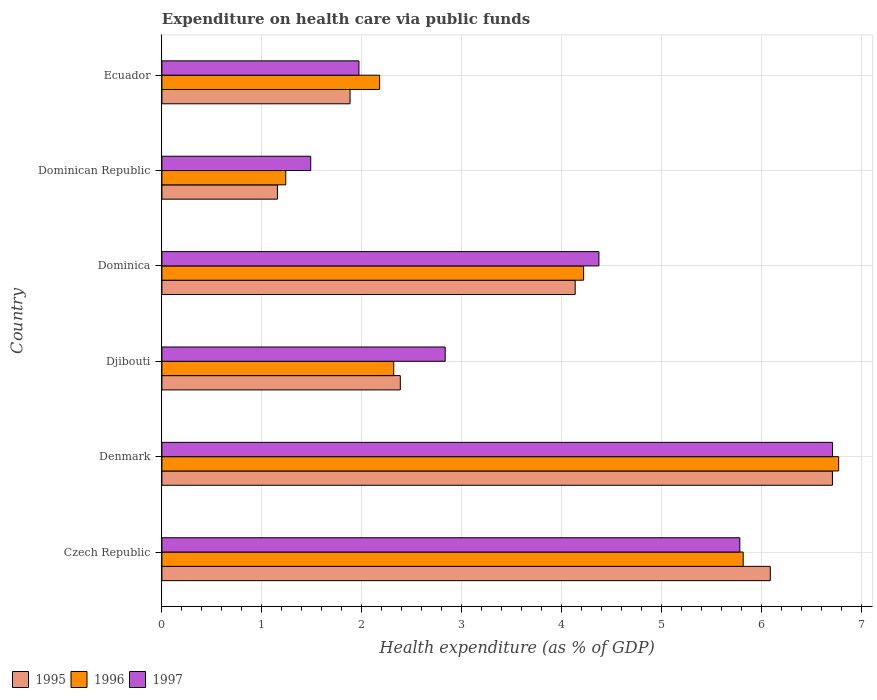How many different coloured bars are there?
Give a very brief answer. 3. Are the number of bars on each tick of the Y-axis equal?
Your answer should be very brief. Yes. What is the label of the 6th group of bars from the top?
Your response must be concise. Czech Republic. What is the expenditure made on health care in 1997 in Djibouti?
Give a very brief answer. 2.83. Across all countries, what is the maximum expenditure made on health care in 1995?
Give a very brief answer. 6.71. Across all countries, what is the minimum expenditure made on health care in 1996?
Give a very brief answer. 1.24. In which country was the expenditure made on health care in 1996 minimum?
Provide a short and direct response. Dominican Republic. What is the total expenditure made on health care in 1995 in the graph?
Keep it short and to the point. 22.34. What is the difference between the expenditure made on health care in 1997 in Czech Republic and that in Dominican Republic?
Provide a succinct answer. 4.29. What is the difference between the expenditure made on health care in 1995 in Denmark and the expenditure made on health care in 1997 in Dominica?
Offer a terse response. 2.34. What is the average expenditure made on health care in 1996 per country?
Make the answer very short. 3.76. What is the difference between the expenditure made on health care in 1996 and expenditure made on health care in 1995 in Dominica?
Give a very brief answer. 0.08. What is the ratio of the expenditure made on health care in 1996 in Denmark to that in Dominican Republic?
Provide a succinct answer. 5.46. Is the difference between the expenditure made on health care in 1996 in Dominica and Dominican Republic greater than the difference between the expenditure made on health care in 1995 in Dominica and Dominican Republic?
Your answer should be compact. Yes. What is the difference between the highest and the second highest expenditure made on health care in 1996?
Offer a terse response. 0.95. What is the difference between the highest and the lowest expenditure made on health care in 1997?
Give a very brief answer. 5.22. Is the sum of the expenditure made on health care in 1997 in Denmark and Dominica greater than the maximum expenditure made on health care in 1996 across all countries?
Provide a short and direct response. Yes. What does the 3rd bar from the bottom in Ecuador represents?
Provide a short and direct response. 1997. Are all the bars in the graph horizontal?
Your response must be concise. Yes. Does the graph contain any zero values?
Ensure brevity in your answer.  No. Does the graph contain grids?
Make the answer very short. Yes. Where does the legend appear in the graph?
Offer a terse response. Bottom left. How many legend labels are there?
Provide a succinct answer. 3. What is the title of the graph?
Ensure brevity in your answer.  Expenditure on health care via public funds. What is the label or title of the X-axis?
Your response must be concise. Health expenditure (as % of GDP). What is the label or title of the Y-axis?
Ensure brevity in your answer.  Country. What is the Health expenditure (as % of GDP) of 1995 in Czech Republic?
Keep it short and to the point. 6.08. What is the Health expenditure (as % of GDP) of 1996 in Czech Republic?
Provide a short and direct response. 5.81. What is the Health expenditure (as % of GDP) of 1997 in Czech Republic?
Provide a succinct answer. 5.78. What is the Health expenditure (as % of GDP) of 1995 in Denmark?
Give a very brief answer. 6.71. What is the Health expenditure (as % of GDP) of 1996 in Denmark?
Provide a short and direct response. 6.77. What is the Health expenditure (as % of GDP) of 1997 in Denmark?
Give a very brief answer. 6.71. What is the Health expenditure (as % of GDP) of 1995 in Djibouti?
Make the answer very short. 2.38. What is the Health expenditure (as % of GDP) of 1996 in Djibouti?
Provide a succinct answer. 2.32. What is the Health expenditure (as % of GDP) in 1997 in Djibouti?
Offer a very short reply. 2.83. What is the Health expenditure (as % of GDP) in 1995 in Dominica?
Your answer should be very brief. 4.13. What is the Health expenditure (as % of GDP) in 1996 in Dominica?
Offer a terse response. 4.22. What is the Health expenditure (as % of GDP) in 1997 in Dominica?
Your response must be concise. 4.37. What is the Health expenditure (as % of GDP) of 1995 in Dominican Republic?
Make the answer very short. 1.16. What is the Health expenditure (as % of GDP) in 1996 in Dominican Republic?
Give a very brief answer. 1.24. What is the Health expenditure (as % of GDP) of 1997 in Dominican Republic?
Ensure brevity in your answer.  1.49. What is the Health expenditure (as % of GDP) of 1995 in Ecuador?
Offer a very short reply. 1.88. What is the Health expenditure (as % of GDP) of 1996 in Ecuador?
Your answer should be very brief. 2.18. What is the Health expenditure (as % of GDP) in 1997 in Ecuador?
Your answer should be compact. 1.97. Across all countries, what is the maximum Health expenditure (as % of GDP) in 1995?
Ensure brevity in your answer.  6.71. Across all countries, what is the maximum Health expenditure (as % of GDP) of 1996?
Give a very brief answer. 6.77. Across all countries, what is the maximum Health expenditure (as % of GDP) in 1997?
Your answer should be very brief. 6.71. Across all countries, what is the minimum Health expenditure (as % of GDP) of 1995?
Your response must be concise. 1.16. Across all countries, what is the minimum Health expenditure (as % of GDP) of 1996?
Make the answer very short. 1.24. Across all countries, what is the minimum Health expenditure (as % of GDP) in 1997?
Ensure brevity in your answer.  1.49. What is the total Health expenditure (as % of GDP) in 1995 in the graph?
Your answer should be compact. 22.34. What is the total Health expenditure (as % of GDP) in 1996 in the graph?
Keep it short and to the point. 22.53. What is the total Health expenditure (as % of GDP) of 1997 in the graph?
Make the answer very short. 23.15. What is the difference between the Health expenditure (as % of GDP) of 1995 in Czech Republic and that in Denmark?
Keep it short and to the point. -0.62. What is the difference between the Health expenditure (as % of GDP) in 1996 in Czech Republic and that in Denmark?
Your response must be concise. -0.95. What is the difference between the Health expenditure (as % of GDP) in 1997 in Czech Republic and that in Denmark?
Your response must be concise. -0.93. What is the difference between the Health expenditure (as % of GDP) in 1995 in Czech Republic and that in Djibouti?
Your answer should be very brief. 3.7. What is the difference between the Health expenditure (as % of GDP) of 1996 in Czech Republic and that in Djibouti?
Give a very brief answer. 3.49. What is the difference between the Health expenditure (as % of GDP) in 1997 in Czech Republic and that in Djibouti?
Your answer should be compact. 2.95. What is the difference between the Health expenditure (as % of GDP) in 1995 in Czech Republic and that in Dominica?
Make the answer very short. 1.95. What is the difference between the Health expenditure (as % of GDP) of 1996 in Czech Republic and that in Dominica?
Provide a short and direct response. 1.6. What is the difference between the Health expenditure (as % of GDP) of 1997 in Czech Republic and that in Dominica?
Provide a succinct answer. 1.41. What is the difference between the Health expenditure (as % of GDP) in 1995 in Czech Republic and that in Dominican Republic?
Your response must be concise. 4.93. What is the difference between the Health expenditure (as % of GDP) in 1996 in Czech Republic and that in Dominican Republic?
Your response must be concise. 4.57. What is the difference between the Health expenditure (as % of GDP) in 1997 in Czech Republic and that in Dominican Republic?
Offer a terse response. 4.29. What is the difference between the Health expenditure (as % of GDP) in 1995 in Czech Republic and that in Ecuador?
Make the answer very short. 4.2. What is the difference between the Health expenditure (as % of GDP) in 1996 in Czech Republic and that in Ecuador?
Provide a short and direct response. 3.64. What is the difference between the Health expenditure (as % of GDP) of 1997 in Czech Republic and that in Ecuador?
Provide a short and direct response. 3.81. What is the difference between the Health expenditure (as % of GDP) in 1995 in Denmark and that in Djibouti?
Your answer should be very brief. 4.32. What is the difference between the Health expenditure (as % of GDP) in 1996 in Denmark and that in Djibouti?
Offer a very short reply. 4.45. What is the difference between the Health expenditure (as % of GDP) in 1997 in Denmark and that in Djibouti?
Keep it short and to the point. 3.87. What is the difference between the Health expenditure (as % of GDP) in 1995 in Denmark and that in Dominica?
Offer a very short reply. 2.57. What is the difference between the Health expenditure (as % of GDP) of 1996 in Denmark and that in Dominica?
Provide a short and direct response. 2.55. What is the difference between the Health expenditure (as % of GDP) in 1997 in Denmark and that in Dominica?
Ensure brevity in your answer.  2.34. What is the difference between the Health expenditure (as % of GDP) in 1995 in Denmark and that in Dominican Republic?
Your answer should be compact. 5.55. What is the difference between the Health expenditure (as % of GDP) of 1996 in Denmark and that in Dominican Republic?
Offer a very short reply. 5.53. What is the difference between the Health expenditure (as % of GDP) of 1997 in Denmark and that in Dominican Republic?
Offer a very short reply. 5.22. What is the difference between the Health expenditure (as % of GDP) of 1995 in Denmark and that in Ecuador?
Ensure brevity in your answer.  4.82. What is the difference between the Health expenditure (as % of GDP) of 1996 in Denmark and that in Ecuador?
Give a very brief answer. 4.59. What is the difference between the Health expenditure (as % of GDP) in 1997 in Denmark and that in Ecuador?
Your response must be concise. 4.74. What is the difference between the Health expenditure (as % of GDP) of 1995 in Djibouti and that in Dominica?
Keep it short and to the point. -1.75. What is the difference between the Health expenditure (as % of GDP) in 1996 in Djibouti and that in Dominica?
Ensure brevity in your answer.  -1.9. What is the difference between the Health expenditure (as % of GDP) in 1997 in Djibouti and that in Dominica?
Give a very brief answer. -1.54. What is the difference between the Health expenditure (as % of GDP) in 1995 in Djibouti and that in Dominican Republic?
Offer a terse response. 1.23. What is the difference between the Health expenditure (as % of GDP) in 1996 in Djibouti and that in Dominican Republic?
Keep it short and to the point. 1.08. What is the difference between the Health expenditure (as % of GDP) in 1997 in Djibouti and that in Dominican Republic?
Provide a short and direct response. 1.34. What is the difference between the Health expenditure (as % of GDP) in 1995 in Djibouti and that in Ecuador?
Ensure brevity in your answer.  0.5. What is the difference between the Health expenditure (as % of GDP) in 1996 in Djibouti and that in Ecuador?
Give a very brief answer. 0.14. What is the difference between the Health expenditure (as % of GDP) in 1997 in Djibouti and that in Ecuador?
Provide a short and direct response. 0.86. What is the difference between the Health expenditure (as % of GDP) in 1995 in Dominica and that in Dominican Republic?
Offer a terse response. 2.98. What is the difference between the Health expenditure (as % of GDP) of 1996 in Dominica and that in Dominican Republic?
Offer a terse response. 2.98. What is the difference between the Health expenditure (as % of GDP) in 1997 in Dominica and that in Dominican Republic?
Keep it short and to the point. 2.88. What is the difference between the Health expenditure (as % of GDP) in 1995 in Dominica and that in Ecuador?
Keep it short and to the point. 2.25. What is the difference between the Health expenditure (as % of GDP) of 1996 in Dominica and that in Ecuador?
Provide a short and direct response. 2.04. What is the difference between the Health expenditure (as % of GDP) of 1997 in Dominica and that in Ecuador?
Keep it short and to the point. 2.4. What is the difference between the Health expenditure (as % of GDP) in 1995 in Dominican Republic and that in Ecuador?
Give a very brief answer. -0.73. What is the difference between the Health expenditure (as % of GDP) of 1996 in Dominican Republic and that in Ecuador?
Provide a short and direct response. -0.94. What is the difference between the Health expenditure (as % of GDP) in 1997 in Dominican Republic and that in Ecuador?
Offer a very short reply. -0.48. What is the difference between the Health expenditure (as % of GDP) in 1995 in Czech Republic and the Health expenditure (as % of GDP) in 1996 in Denmark?
Your response must be concise. -0.68. What is the difference between the Health expenditure (as % of GDP) in 1995 in Czech Republic and the Health expenditure (as % of GDP) in 1997 in Denmark?
Keep it short and to the point. -0.62. What is the difference between the Health expenditure (as % of GDP) in 1996 in Czech Republic and the Health expenditure (as % of GDP) in 1997 in Denmark?
Make the answer very short. -0.89. What is the difference between the Health expenditure (as % of GDP) in 1995 in Czech Republic and the Health expenditure (as % of GDP) in 1996 in Djibouti?
Your answer should be very brief. 3.77. What is the difference between the Health expenditure (as % of GDP) of 1995 in Czech Republic and the Health expenditure (as % of GDP) of 1997 in Djibouti?
Keep it short and to the point. 3.25. What is the difference between the Health expenditure (as % of GDP) of 1996 in Czech Republic and the Health expenditure (as % of GDP) of 1997 in Djibouti?
Offer a very short reply. 2.98. What is the difference between the Health expenditure (as % of GDP) in 1995 in Czech Republic and the Health expenditure (as % of GDP) in 1996 in Dominica?
Ensure brevity in your answer.  1.87. What is the difference between the Health expenditure (as % of GDP) of 1995 in Czech Republic and the Health expenditure (as % of GDP) of 1997 in Dominica?
Offer a very short reply. 1.71. What is the difference between the Health expenditure (as % of GDP) of 1996 in Czech Republic and the Health expenditure (as % of GDP) of 1997 in Dominica?
Ensure brevity in your answer.  1.44. What is the difference between the Health expenditure (as % of GDP) in 1995 in Czech Republic and the Health expenditure (as % of GDP) in 1996 in Dominican Republic?
Your answer should be very brief. 4.85. What is the difference between the Health expenditure (as % of GDP) of 1995 in Czech Republic and the Health expenditure (as % of GDP) of 1997 in Dominican Republic?
Keep it short and to the point. 4.6. What is the difference between the Health expenditure (as % of GDP) in 1996 in Czech Republic and the Health expenditure (as % of GDP) in 1997 in Dominican Republic?
Keep it short and to the point. 4.32. What is the difference between the Health expenditure (as % of GDP) of 1995 in Czech Republic and the Health expenditure (as % of GDP) of 1996 in Ecuador?
Give a very brief answer. 3.91. What is the difference between the Health expenditure (as % of GDP) of 1995 in Czech Republic and the Health expenditure (as % of GDP) of 1997 in Ecuador?
Offer a very short reply. 4.11. What is the difference between the Health expenditure (as % of GDP) in 1996 in Czech Republic and the Health expenditure (as % of GDP) in 1997 in Ecuador?
Ensure brevity in your answer.  3.84. What is the difference between the Health expenditure (as % of GDP) of 1995 in Denmark and the Health expenditure (as % of GDP) of 1996 in Djibouti?
Provide a short and direct response. 4.39. What is the difference between the Health expenditure (as % of GDP) in 1995 in Denmark and the Health expenditure (as % of GDP) in 1997 in Djibouti?
Offer a very short reply. 3.87. What is the difference between the Health expenditure (as % of GDP) of 1996 in Denmark and the Health expenditure (as % of GDP) of 1997 in Djibouti?
Keep it short and to the point. 3.93. What is the difference between the Health expenditure (as % of GDP) in 1995 in Denmark and the Health expenditure (as % of GDP) in 1996 in Dominica?
Your answer should be very brief. 2.49. What is the difference between the Health expenditure (as % of GDP) in 1995 in Denmark and the Health expenditure (as % of GDP) in 1997 in Dominica?
Offer a terse response. 2.34. What is the difference between the Health expenditure (as % of GDP) in 1996 in Denmark and the Health expenditure (as % of GDP) in 1997 in Dominica?
Make the answer very short. 2.4. What is the difference between the Health expenditure (as % of GDP) of 1995 in Denmark and the Health expenditure (as % of GDP) of 1996 in Dominican Republic?
Your answer should be very brief. 5.47. What is the difference between the Health expenditure (as % of GDP) in 1995 in Denmark and the Health expenditure (as % of GDP) in 1997 in Dominican Republic?
Give a very brief answer. 5.22. What is the difference between the Health expenditure (as % of GDP) of 1996 in Denmark and the Health expenditure (as % of GDP) of 1997 in Dominican Republic?
Offer a terse response. 5.28. What is the difference between the Health expenditure (as % of GDP) in 1995 in Denmark and the Health expenditure (as % of GDP) in 1996 in Ecuador?
Offer a very short reply. 4.53. What is the difference between the Health expenditure (as % of GDP) in 1995 in Denmark and the Health expenditure (as % of GDP) in 1997 in Ecuador?
Give a very brief answer. 4.73. What is the difference between the Health expenditure (as % of GDP) in 1996 in Denmark and the Health expenditure (as % of GDP) in 1997 in Ecuador?
Offer a terse response. 4.8. What is the difference between the Health expenditure (as % of GDP) in 1995 in Djibouti and the Health expenditure (as % of GDP) in 1996 in Dominica?
Give a very brief answer. -1.83. What is the difference between the Health expenditure (as % of GDP) of 1995 in Djibouti and the Health expenditure (as % of GDP) of 1997 in Dominica?
Make the answer very short. -1.99. What is the difference between the Health expenditure (as % of GDP) in 1996 in Djibouti and the Health expenditure (as % of GDP) in 1997 in Dominica?
Provide a succinct answer. -2.05. What is the difference between the Health expenditure (as % of GDP) of 1995 in Djibouti and the Health expenditure (as % of GDP) of 1996 in Dominican Republic?
Keep it short and to the point. 1.15. What is the difference between the Health expenditure (as % of GDP) of 1995 in Djibouti and the Health expenditure (as % of GDP) of 1997 in Dominican Republic?
Keep it short and to the point. 0.9. What is the difference between the Health expenditure (as % of GDP) of 1996 in Djibouti and the Health expenditure (as % of GDP) of 1997 in Dominican Republic?
Ensure brevity in your answer.  0.83. What is the difference between the Health expenditure (as % of GDP) of 1995 in Djibouti and the Health expenditure (as % of GDP) of 1996 in Ecuador?
Provide a short and direct response. 0.21. What is the difference between the Health expenditure (as % of GDP) in 1995 in Djibouti and the Health expenditure (as % of GDP) in 1997 in Ecuador?
Your answer should be very brief. 0.41. What is the difference between the Health expenditure (as % of GDP) of 1996 in Djibouti and the Health expenditure (as % of GDP) of 1997 in Ecuador?
Provide a succinct answer. 0.35. What is the difference between the Health expenditure (as % of GDP) in 1995 in Dominica and the Health expenditure (as % of GDP) in 1996 in Dominican Republic?
Provide a short and direct response. 2.89. What is the difference between the Health expenditure (as % of GDP) of 1995 in Dominica and the Health expenditure (as % of GDP) of 1997 in Dominican Republic?
Your response must be concise. 2.64. What is the difference between the Health expenditure (as % of GDP) of 1996 in Dominica and the Health expenditure (as % of GDP) of 1997 in Dominican Republic?
Provide a short and direct response. 2.73. What is the difference between the Health expenditure (as % of GDP) of 1995 in Dominica and the Health expenditure (as % of GDP) of 1996 in Ecuador?
Provide a succinct answer. 1.96. What is the difference between the Health expenditure (as % of GDP) in 1995 in Dominica and the Health expenditure (as % of GDP) in 1997 in Ecuador?
Provide a short and direct response. 2.16. What is the difference between the Health expenditure (as % of GDP) of 1996 in Dominica and the Health expenditure (as % of GDP) of 1997 in Ecuador?
Your answer should be very brief. 2.25. What is the difference between the Health expenditure (as % of GDP) of 1995 in Dominican Republic and the Health expenditure (as % of GDP) of 1996 in Ecuador?
Provide a short and direct response. -1.02. What is the difference between the Health expenditure (as % of GDP) of 1995 in Dominican Republic and the Health expenditure (as % of GDP) of 1997 in Ecuador?
Ensure brevity in your answer.  -0.82. What is the difference between the Health expenditure (as % of GDP) of 1996 in Dominican Republic and the Health expenditure (as % of GDP) of 1997 in Ecuador?
Keep it short and to the point. -0.73. What is the average Health expenditure (as % of GDP) of 1995 per country?
Keep it short and to the point. 3.72. What is the average Health expenditure (as % of GDP) of 1996 per country?
Your answer should be very brief. 3.76. What is the average Health expenditure (as % of GDP) in 1997 per country?
Make the answer very short. 3.86. What is the difference between the Health expenditure (as % of GDP) in 1995 and Health expenditure (as % of GDP) in 1996 in Czech Republic?
Provide a short and direct response. 0.27. What is the difference between the Health expenditure (as % of GDP) in 1995 and Health expenditure (as % of GDP) in 1997 in Czech Republic?
Offer a terse response. 0.3. What is the difference between the Health expenditure (as % of GDP) of 1996 and Health expenditure (as % of GDP) of 1997 in Czech Republic?
Your response must be concise. 0.03. What is the difference between the Health expenditure (as % of GDP) of 1995 and Health expenditure (as % of GDP) of 1996 in Denmark?
Provide a succinct answer. -0.06. What is the difference between the Health expenditure (as % of GDP) in 1995 and Health expenditure (as % of GDP) in 1997 in Denmark?
Offer a very short reply. -0. What is the difference between the Health expenditure (as % of GDP) in 1996 and Health expenditure (as % of GDP) in 1997 in Denmark?
Keep it short and to the point. 0.06. What is the difference between the Health expenditure (as % of GDP) in 1995 and Health expenditure (as % of GDP) in 1996 in Djibouti?
Your answer should be very brief. 0.07. What is the difference between the Health expenditure (as % of GDP) of 1995 and Health expenditure (as % of GDP) of 1997 in Djibouti?
Keep it short and to the point. -0.45. What is the difference between the Health expenditure (as % of GDP) of 1996 and Health expenditure (as % of GDP) of 1997 in Djibouti?
Offer a very short reply. -0.51. What is the difference between the Health expenditure (as % of GDP) of 1995 and Health expenditure (as % of GDP) of 1996 in Dominica?
Your response must be concise. -0.08. What is the difference between the Health expenditure (as % of GDP) of 1995 and Health expenditure (as % of GDP) of 1997 in Dominica?
Your answer should be very brief. -0.24. What is the difference between the Health expenditure (as % of GDP) in 1996 and Health expenditure (as % of GDP) in 1997 in Dominica?
Provide a short and direct response. -0.15. What is the difference between the Health expenditure (as % of GDP) in 1995 and Health expenditure (as % of GDP) in 1996 in Dominican Republic?
Provide a succinct answer. -0.08. What is the difference between the Health expenditure (as % of GDP) of 1995 and Health expenditure (as % of GDP) of 1997 in Dominican Republic?
Your answer should be very brief. -0.33. What is the difference between the Health expenditure (as % of GDP) of 1996 and Health expenditure (as % of GDP) of 1997 in Dominican Republic?
Give a very brief answer. -0.25. What is the difference between the Health expenditure (as % of GDP) of 1995 and Health expenditure (as % of GDP) of 1996 in Ecuador?
Keep it short and to the point. -0.3. What is the difference between the Health expenditure (as % of GDP) in 1995 and Health expenditure (as % of GDP) in 1997 in Ecuador?
Keep it short and to the point. -0.09. What is the difference between the Health expenditure (as % of GDP) in 1996 and Health expenditure (as % of GDP) in 1997 in Ecuador?
Ensure brevity in your answer.  0.21. What is the ratio of the Health expenditure (as % of GDP) in 1995 in Czech Republic to that in Denmark?
Provide a short and direct response. 0.91. What is the ratio of the Health expenditure (as % of GDP) of 1996 in Czech Republic to that in Denmark?
Offer a terse response. 0.86. What is the ratio of the Health expenditure (as % of GDP) in 1997 in Czech Republic to that in Denmark?
Your response must be concise. 0.86. What is the ratio of the Health expenditure (as % of GDP) of 1995 in Czech Republic to that in Djibouti?
Ensure brevity in your answer.  2.55. What is the ratio of the Health expenditure (as % of GDP) in 1996 in Czech Republic to that in Djibouti?
Offer a terse response. 2.51. What is the ratio of the Health expenditure (as % of GDP) in 1997 in Czech Republic to that in Djibouti?
Your answer should be compact. 2.04. What is the ratio of the Health expenditure (as % of GDP) of 1995 in Czech Republic to that in Dominica?
Offer a very short reply. 1.47. What is the ratio of the Health expenditure (as % of GDP) of 1996 in Czech Republic to that in Dominica?
Keep it short and to the point. 1.38. What is the ratio of the Health expenditure (as % of GDP) in 1997 in Czech Republic to that in Dominica?
Provide a short and direct response. 1.32. What is the ratio of the Health expenditure (as % of GDP) in 1995 in Czech Republic to that in Dominican Republic?
Offer a terse response. 5.27. What is the ratio of the Health expenditure (as % of GDP) of 1996 in Czech Republic to that in Dominican Republic?
Keep it short and to the point. 4.69. What is the ratio of the Health expenditure (as % of GDP) of 1997 in Czech Republic to that in Dominican Republic?
Give a very brief answer. 3.88. What is the ratio of the Health expenditure (as % of GDP) of 1995 in Czech Republic to that in Ecuador?
Offer a very short reply. 3.23. What is the ratio of the Health expenditure (as % of GDP) of 1996 in Czech Republic to that in Ecuador?
Your answer should be compact. 2.67. What is the ratio of the Health expenditure (as % of GDP) in 1997 in Czech Republic to that in Ecuador?
Make the answer very short. 2.93. What is the ratio of the Health expenditure (as % of GDP) in 1995 in Denmark to that in Djibouti?
Your response must be concise. 2.81. What is the ratio of the Health expenditure (as % of GDP) of 1996 in Denmark to that in Djibouti?
Your answer should be compact. 2.92. What is the ratio of the Health expenditure (as % of GDP) of 1997 in Denmark to that in Djibouti?
Ensure brevity in your answer.  2.37. What is the ratio of the Health expenditure (as % of GDP) of 1995 in Denmark to that in Dominica?
Make the answer very short. 1.62. What is the ratio of the Health expenditure (as % of GDP) of 1996 in Denmark to that in Dominica?
Provide a succinct answer. 1.6. What is the ratio of the Health expenditure (as % of GDP) in 1997 in Denmark to that in Dominica?
Your answer should be very brief. 1.53. What is the ratio of the Health expenditure (as % of GDP) in 1995 in Denmark to that in Dominican Republic?
Keep it short and to the point. 5.8. What is the ratio of the Health expenditure (as % of GDP) in 1996 in Denmark to that in Dominican Republic?
Your answer should be compact. 5.46. What is the ratio of the Health expenditure (as % of GDP) in 1997 in Denmark to that in Dominican Republic?
Make the answer very short. 4.51. What is the ratio of the Health expenditure (as % of GDP) in 1995 in Denmark to that in Ecuador?
Give a very brief answer. 3.56. What is the ratio of the Health expenditure (as % of GDP) of 1996 in Denmark to that in Ecuador?
Your answer should be very brief. 3.11. What is the ratio of the Health expenditure (as % of GDP) in 1997 in Denmark to that in Ecuador?
Give a very brief answer. 3.4. What is the ratio of the Health expenditure (as % of GDP) of 1995 in Djibouti to that in Dominica?
Your answer should be compact. 0.58. What is the ratio of the Health expenditure (as % of GDP) in 1996 in Djibouti to that in Dominica?
Your response must be concise. 0.55. What is the ratio of the Health expenditure (as % of GDP) of 1997 in Djibouti to that in Dominica?
Give a very brief answer. 0.65. What is the ratio of the Health expenditure (as % of GDP) of 1995 in Djibouti to that in Dominican Republic?
Provide a succinct answer. 2.06. What is the ratio of the Health expenditure (as % of GDP) in 1996 in Djibouti to that in Dominican Republic?
Offer a terse response. 1.87. What is the ratio of the Health expenditure (as % of GDP) in 1997 in Djibouti to that in Dominican Republic?
Your answer should be very brief. 1.9. What is the ratio of the Health expenditure (as % of GDP) in 1995 in Djibouti to that in Ecuador?
Provide a short and direct response. 1.27. What is the ratio of the Health expenditure (as % of GDP) of 1996 in Djibouti to that in Ecuador?
Provide a succinct answer. 1.06. What is the ratio of the Health expenditure (as % of GDP) in 1997 in Djibouti to that in Ecuador?
Provide a succinct answer. 1.44. What is the ratio of the Health expenditure (as % of GDP) in 1995 in Dominica to that in Dominican Republic?
Your response must be concise. 3.58. What is the ratio of the Health expenditure (as % of GDP) of 1996 in Dominica to that in Dominican Republic?
Your answer should be compact. 3.41. What is the ratio of the Health expenditure (as % of GDP) in 1997 in Dominica to that in Dominican Republic?
Offer a very short reply. 2.94. What is the ratio of the Health expenditure (as % of GDP) of 1995 in Dominica to that in Ecuador?
Offer a terse response. 2.2. What is the ratio of the Health expenditure (as % of GDP) of 1996 in Dominica to that in Ecuador?
Ensure brevity in your answer.  1.94. What is the ratio of the Health expenditure (as % of GDP) of 1997 in Dominica to that in Ecuador?
Provide a short and direct response. 2.22. What is the ratio of the Health expenditure (as % of GDP) in 1995 in Dominican Republic to that in Ecuador?
Provide a succinct answer. 0.61. What is the ratio of the Health expenditure (as % of GDP) of 1996 in Dominican Republic to that in Ecuador?
Offer a very short reply. 0.57. What is the ratio of the Health expenditure (as % of GDP) of 1997 in Dominican Republic to that in Ecuador?
Make the answer very short. 0.76. What is the difference between the highest and the second highest Health expenditure (as % of GDP) in 1995?
Ensure brevity in your answer.  0.62. What is the difference between the highest and the second highest Health expenditure (as % of GDP) of 1996?
Your answer should be compact. 0.95. What is the difference between the highest and the second highest Health expenditure (as % of GDP) of 1997?
Ensure brevity in your answer.  0.93. What is the difference between the highest and the lowest Health expenditure (as % of GDP) in 1995?
Provide a short and direct response. 5.55. What is the difference between the highest and the lowest Health expenditure (as % of GDP) of 1996?
Give a very brief answer. 5.53. What is the difference between the highest and the lowest Health expenditure (as % of GDP) in 1997?
Your response must be concise. 5.22. 